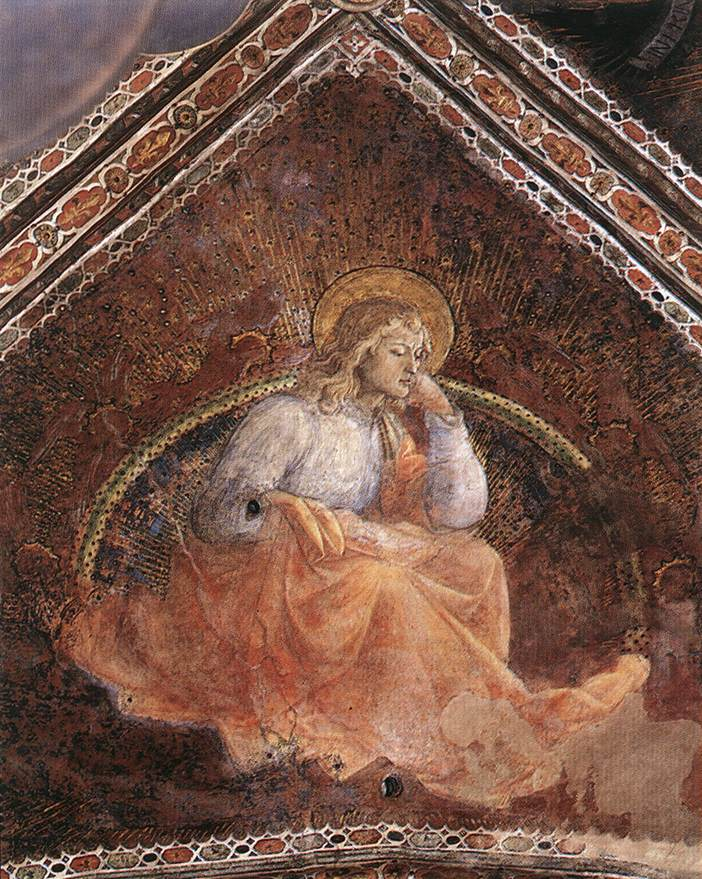Imagine a world where this angel descends to earth. What kind of changes would it bring? If this angel descended to earth, its mere presence would inspire profound changes across the globe. People would be drawn by its purity and the divine light it emanates, fostering a renewed sense of hope and purpose. Acts of kindness would ripple through communities as the angel’s compassion influences hearts and minds. Wars and conflicts might find resolution, guided by the angel’s wisdom and the desire for peace it instills. Poverty and suffering could be alleviated as humanity unites under a common cause inspired by the angel’s teachings. This celestial being would serve as a beacon of purity, a reminder of the divine, and a catalyst for a world striving towards empathy, harmony, and spiritual enlightenment. 